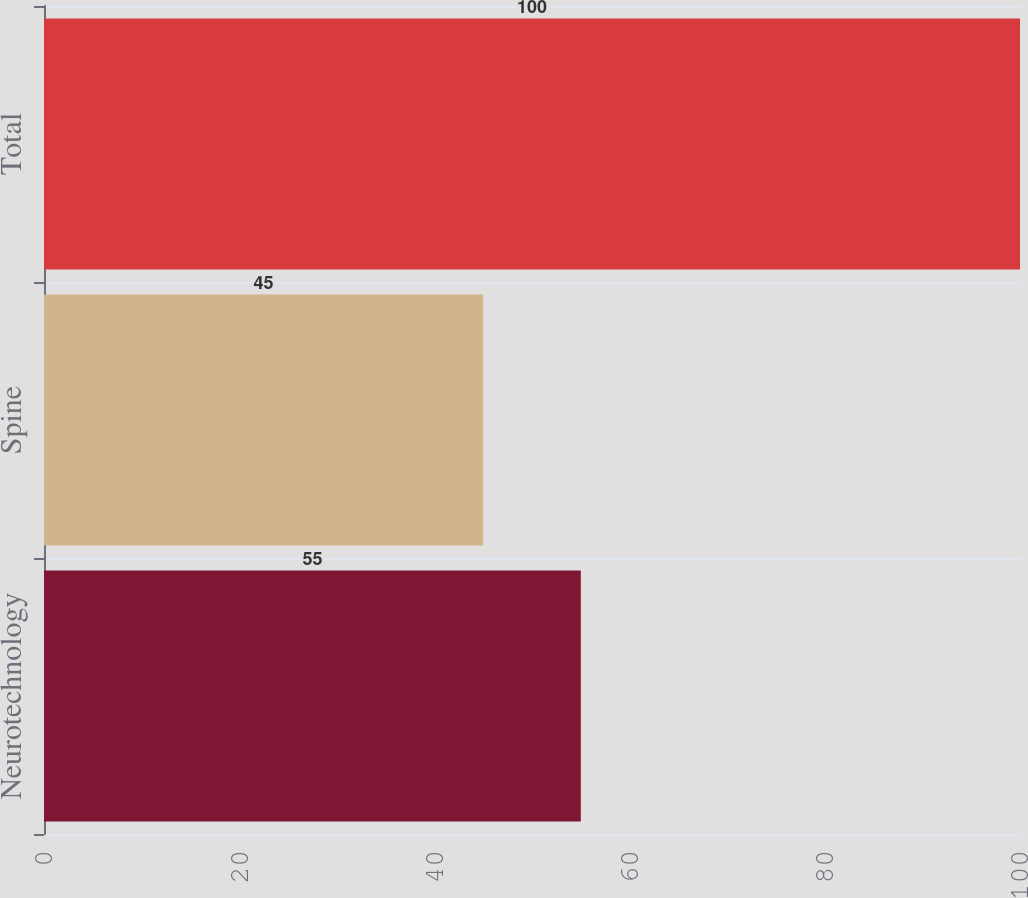Convert chart. <chart><loc_0><loc_0><loc_500><loc_500><bar_chart><fcel>Neurotechnology<fcel>Spine<fcel>Total<nl><fcel>55<fcel>45<fcel>100<nl></chart> 